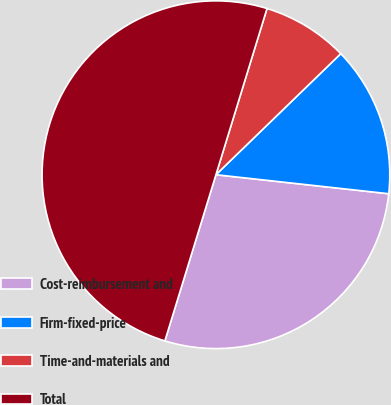<chart> <loc_0><loc_0><loc_500><loc_500><pie_chart><fcel>Cost-reimbursement and<fcel>Firm-fixed-price<fcel>Time-and-materials and<fcel>Total<nl><fcel>28.0%<fcel>14.0%<fcel>8.0%<fcel>50.0%<nl></chart> 